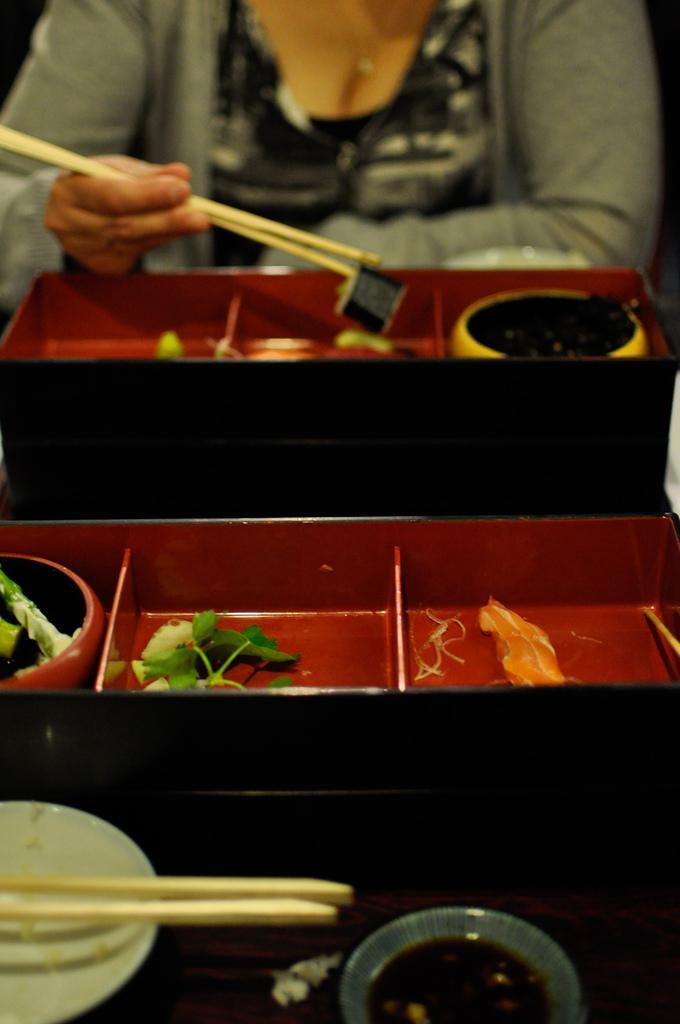Could you give a brief overview of what you see in this image? On this table there is a plate, chopsticks, bowl, containers and food. Beside this table a woman is sitting on a chair wore jacket and holding chopsticks. 